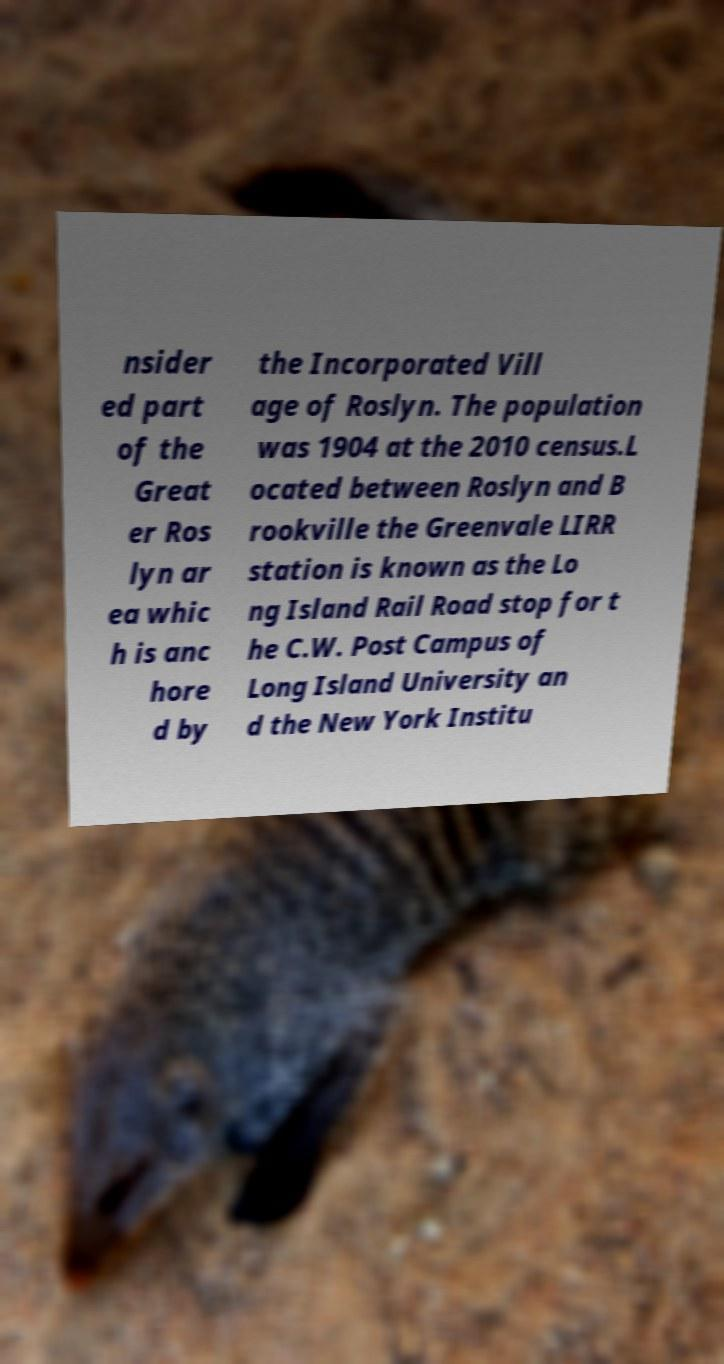Can you accurately transcribe the text from the provided image for me? nsider ed part of the Great er Ros lyn ar ea whic h is anc hore d by the Incorporated Vill age of Roslyn. The population was 1904 at the 2010 census.L ocated between Roslyn and B rookville the Greenvale LIRR station is known as the Lo ng Island Rail Road stop for t he C.W. Post Campus of Long Island University an d the New York Institu 